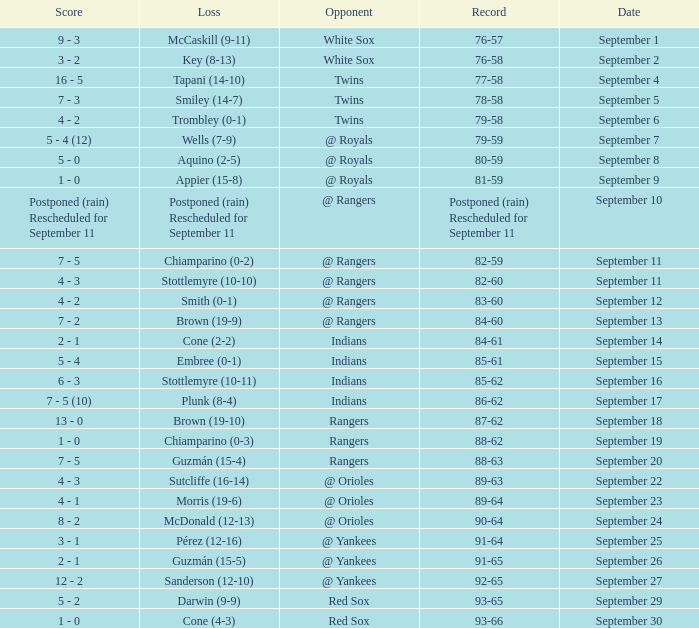What is the result from september 15 with the indians as the adversary? 5 - 4. 